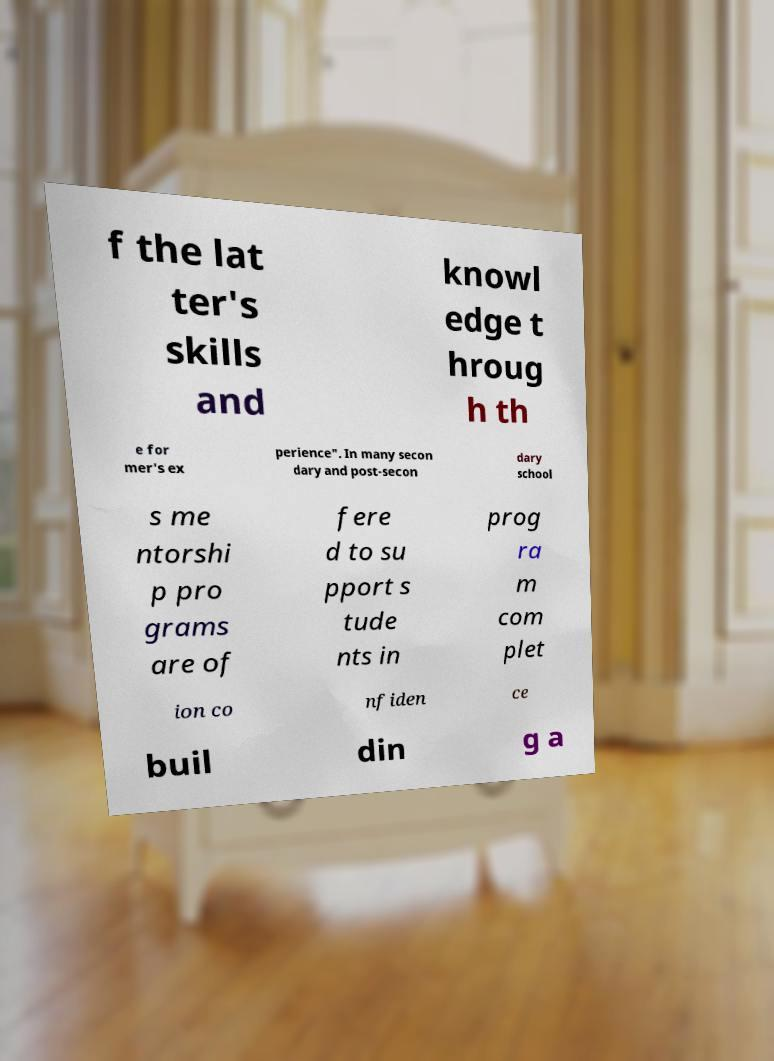Please identify and transcribe the text found in this image. f the lat ter's skills and knowl edge t hroug h th e for mer's ex perience". In many secon dary and post-secon dary school s me ntorshi p pro grams are of fere d to su pport s tude nts in prog ra m com plet ion co nfiden ce buil din g a 